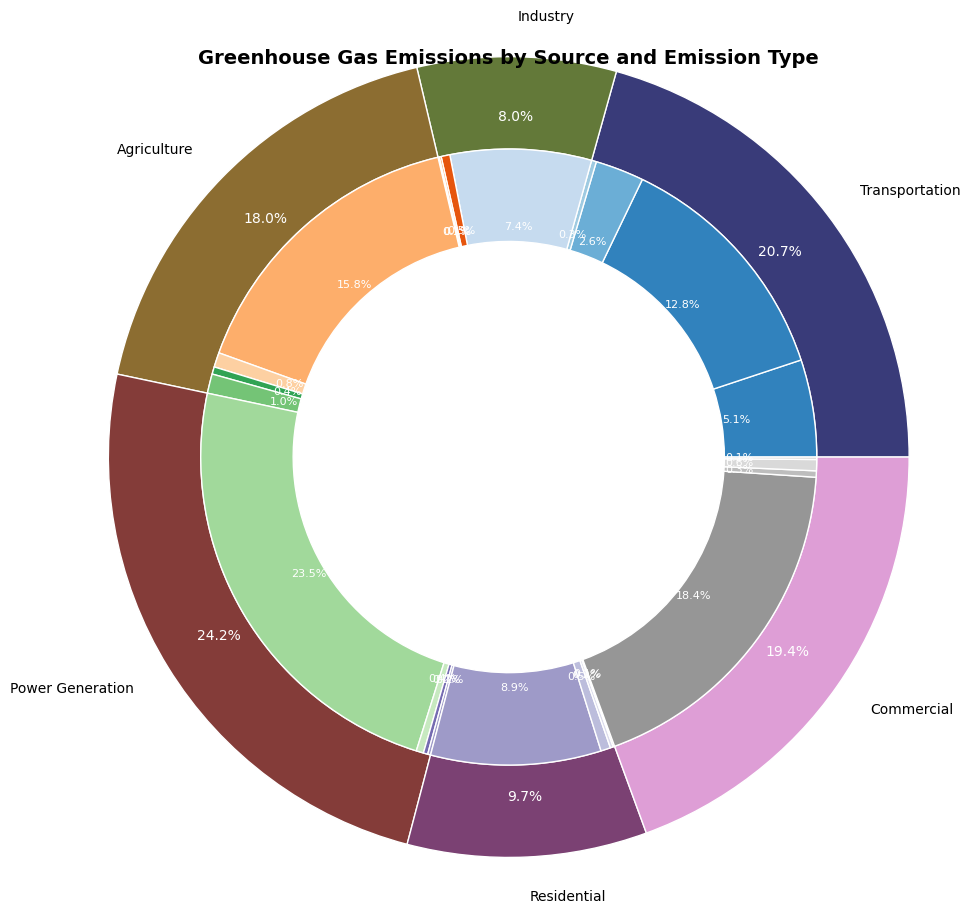Which source contributes the most to greenhouse gas emissions overall? Look at the outer part of the pie chart. The segment with the largest proportion represents the source with the highest emissions.
Answer: Power Generation Which emission type contributes the most within the Transportation sector? Look at the inner segments within the Transportation sector's outer segment. The largest inner segment indicates the emission type with the highest contribution.
Answer: CO2 Which sector emits more CO2: Industry or Residential? Compare the inner segments labeled CO2 under the Industry and Residential sectors. The segment with the larger proportion is the higher emitter.
Answer: Industry What is the combined percentage of Methane and Nitrous Oxide in Agriculture? From the Agriculture sector's inner segments, identify the proportions of Methane and Nitrous Oxide. Sum these percentages to get the combined result. Methane is 55.6% and Nitrous Oxide is 11.1%, summing to 66.7%.
Answer: 66.7% Which sector has the smallest proportion of "Other" emissions? Compare the inner segments labeled "Other" across all sectors. Identify the smallest segment.
Answer: Commercial What is the ratio of CO2 emissions between Power Generation and Agriculture? Identify the inner segments labeled CO2 under Power Generation and Agriculture, respectively. Divide the emissions value of Power Generation's CO2 by Agriculture's CO2. Ratio = 9200 / 2000 = 4.6
Answer: 4.6 What is the total percentage of emissions from Industry and Transportation combined? Identify the proportions of Industry and Transportation in the outer segments. Sum these percentages. Industry is 27.8% and Transportation is 30.2%, resulting in 58%.
Answer: 58% Compare the CO2 emissions of the Commercial sector to those of the Residential sector. Which is higher and by what percentage? Compare the inner CO2 segments of the Commercial and Residential sectors. Subtract the smaller percentage from the larger one to find the difference. Residential CO2 is higher by 10.4% (23.6% - 13.2%).
Answer: Residential by 10.4% What visual attributes differentiate the sectors in the pie chart? Observe the outer segments' colors, widths, and labels. Each sector is represented by distinct colors with labels directly on the segments.
Answer: Colors and labels 